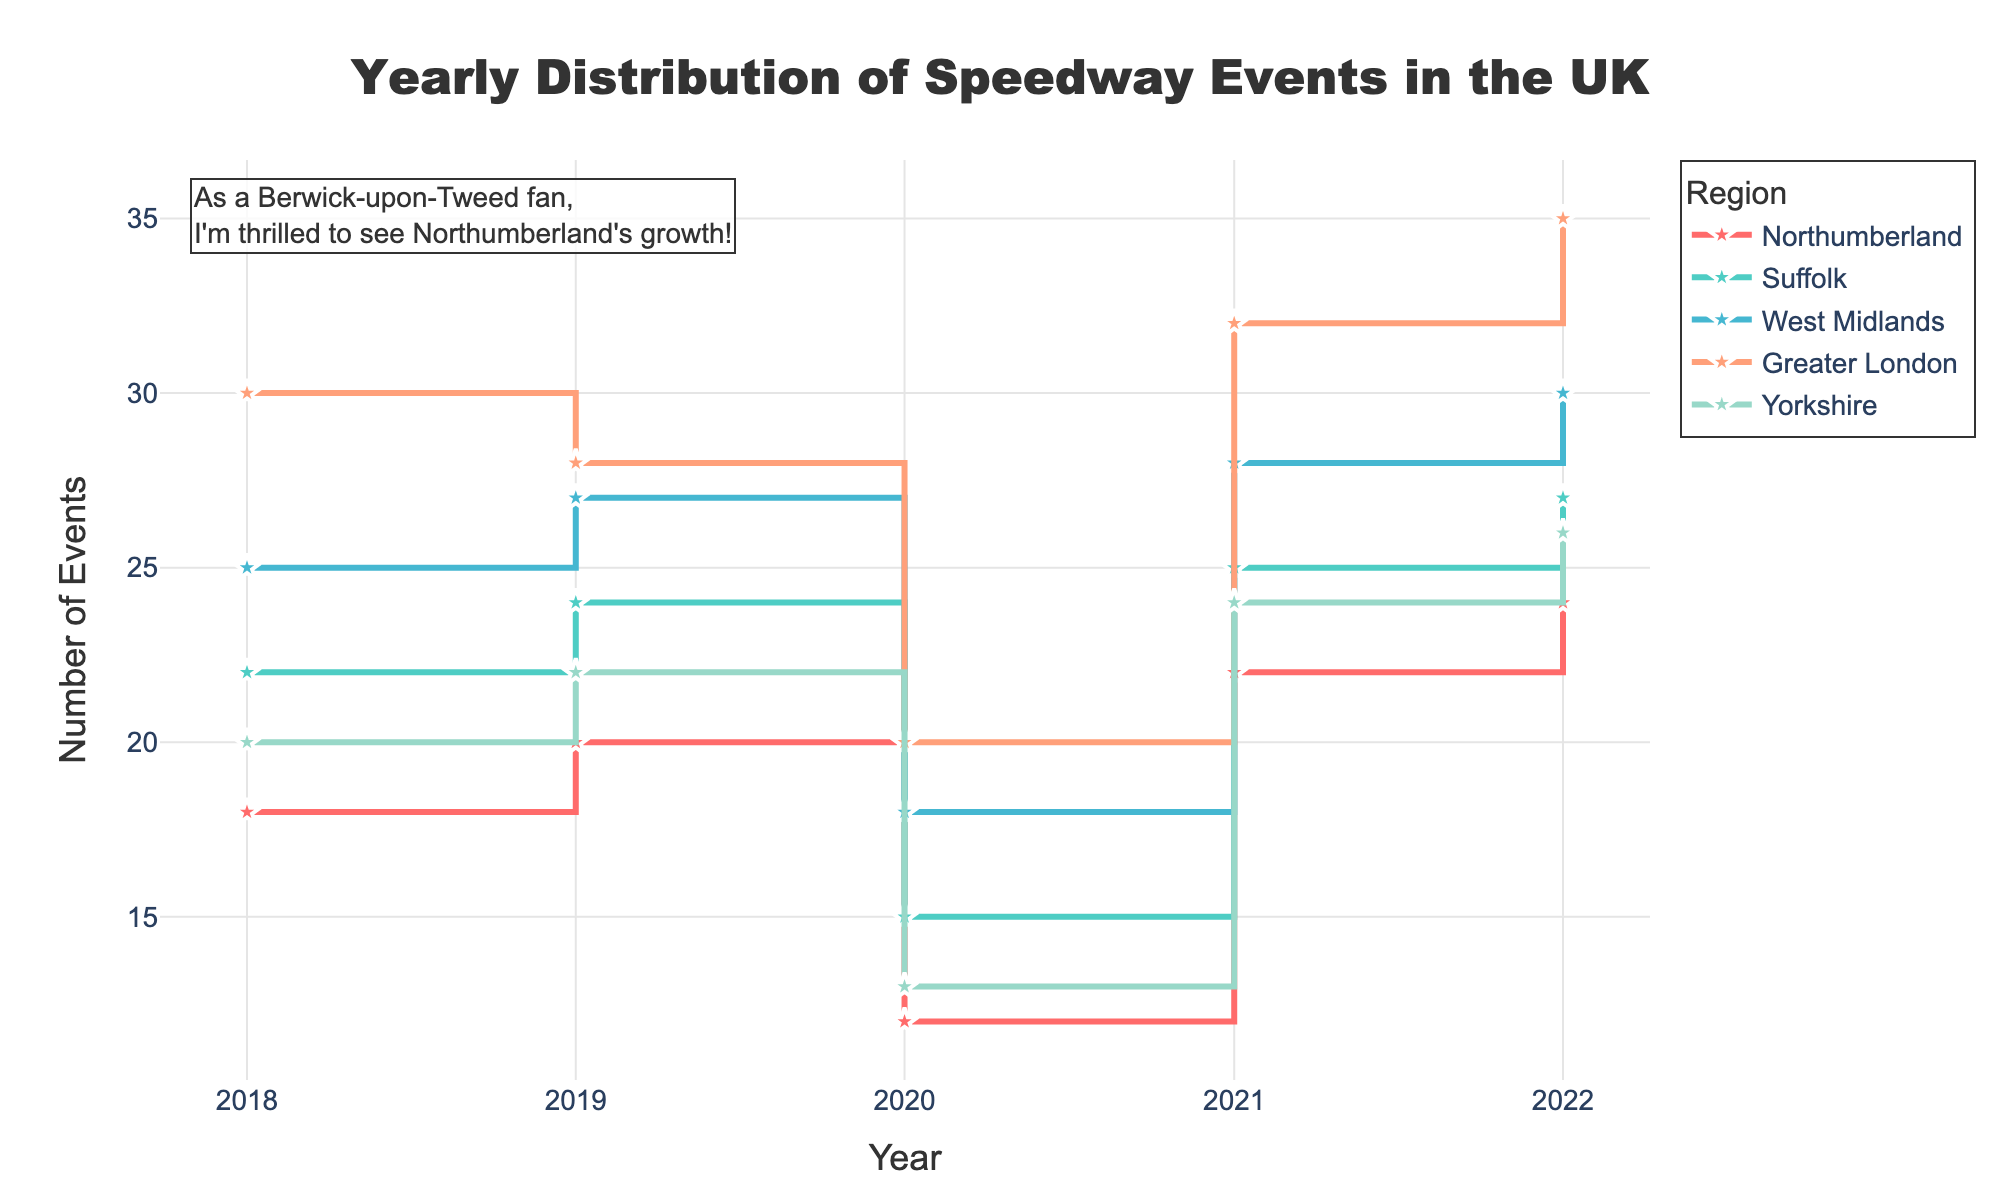What is the title of the plot? The title is displayed prominently at the top of the figure. It reads "Yearly Distribution of Speedway Events in the UK".
Answer: Yearly Distribution of Speedway Events in the UK How many regions are represented in the plot? By observing the legend on the right side of the plot, there are five different regions each represented by different colors.
Answer: Five Which region had the highest number of events in 2018? By looking at the height of the stairs for the year 2018, Greater London had the highest number of events.
Answer: Greater London Compare the number of events in Northumberland between 2020 and 2021. How did it change? By comparing the heights of the stair steps for Northumberland in 2020 and 2021, it increased from 12 events to 22 events.
Answer: Increased by 10 What was the trend for the number of speedway events in Greater London from 2018 to 2022? By following the stair steps for Greater London, the number of events increased every year from 30 in 2018 to 35 in 2022.
Answer: Increasing trend Which year did Yorkshire experience the highest number of events, and how many were there? By observing the stair steps for Yorkshire, the highest number was in 2022 with 26 events.
Answer: 2022, 26 events What is the difference in the popularity score of Suffolk between 2020 and 2022? The popularity score in 2020 was 7.1, and in 2022 it was 8.7. The difference is 8.7 - 7.1 = 1.6.
Answer: 1.6 How many events were held in the West Midlands in 2019, and how does that compare to 2021? In 2019, there were 27 events, and in 2021, there were 28 events. The difference is 28 - 27 = 1.
Answer: 27 in 2019, 1 more in 2021 Compare the popularity score trend of Northumberland and West Midlands from 2018 to 2022. What can you conclude? In Northumberland, the scores vary slightly with an overall increasing trend: 7.5 to 7.8 to 6.5 to 7.9 to 8.1. In the West Midlands, the scores increase steadily, although more consistently: 8.4 to 8.5 to 7.4 to 8.6 to 8.9. Conclusion: Both regions increased in popularity, but Northumberland showed more variability.
Answer: Both regions' popularity increased; Northumberland was more variable 